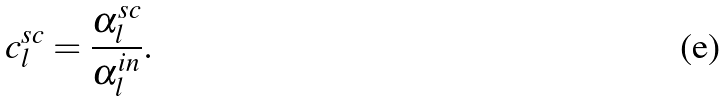Convert formula to latex. <formula><loc_0><loc_0><loc_500><loc_500>c _ { l } ^ { s c } = \frac { \alpha _ { l } ^ { s c } } { \alpha _ { l } ^ { i n } } .</formula> 